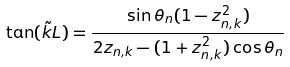Convert formula to latex. <formula><loc_0><loc_0><loc_500><loc_500>\tan ( \tilde { k } L ) = \frac { \sin \theta _ { n } ( 1 - z _ { n , k } ^ { 2 } ) } { 2 z _ { n , k } - ( 1 + z _ { n , k } ^ { 2 } ) \cos \theta _ { n } }</formula> 